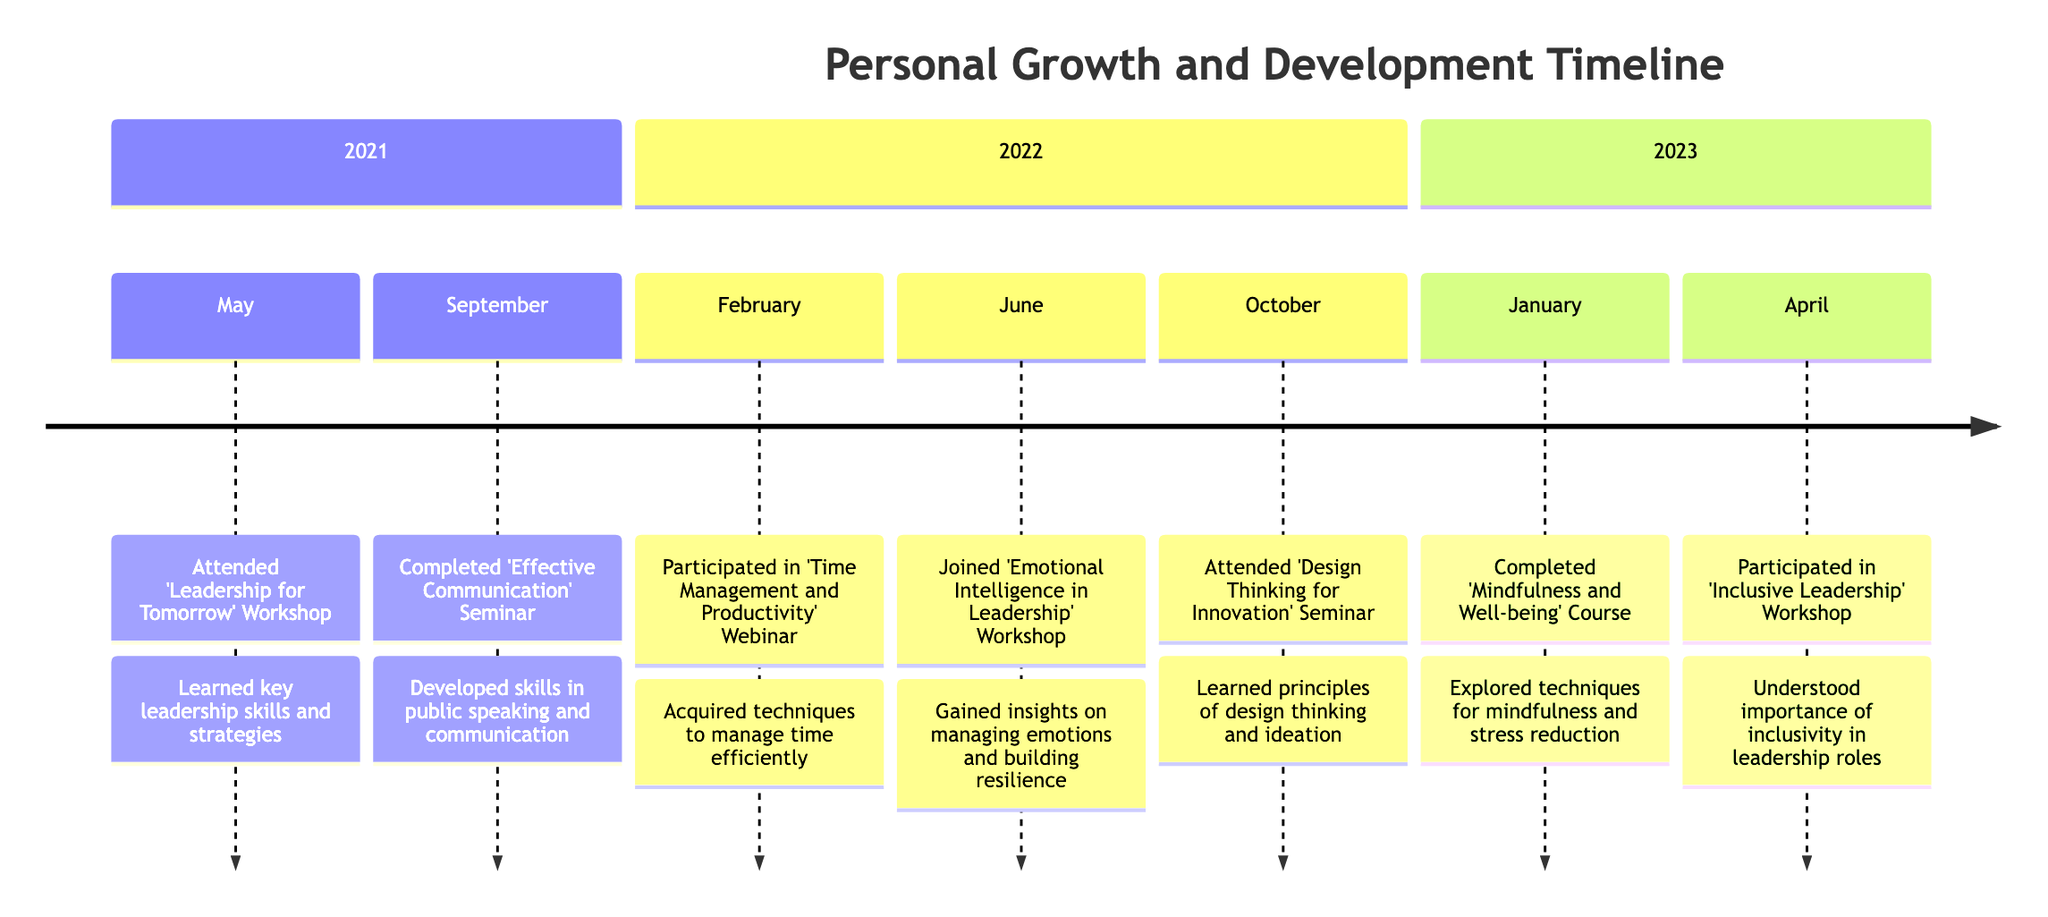What is the title of the timeline? The title is provided at the top of the diagram and states the overall theme of the timeline, specifically focusing on personal growth and development experiences over a specified period.
Answer: Personal Growth and Development Timeline How many workshops are included in the timeline? To determine this, we count the events categorized as workshops within the timeline. According to the entries listed, there are a total of four workshops, including both participating and joined activities.
Answer: 4 Which event occurred in January 2023? By looking at the section for 2023, we find the specific event listed under January, which directly indicates what took place during that month.
Answer: Completed 'Mindfulness and Well-being' Course What skill was developed during the 'Effective Communication' Seminar? The description associated with the 'Effective Communication' Seminar provides information about the specific skills gained from it, highlighting the primary focus of the seminar.
Answer: Public speaking Which workshop focused on emotional intelligence? By reviewing the events listed under the 2022 section, we identify the workshop that specifically emphasizes emotional intelligence, distinguishing it from other events.
Answer: 'Emotional Intelligence in Leadership' Workshop In which month was the 'Inclusive Leadership' Workshop held? We can pinpoint the month by checking the timeline section for 2023 and locating the event that corresponds to 'Inclusive Leadership,' confirming when it took place.
Answer: April What was a key learning from the 'Design Thinking for Innovation' Seminar? The timeline's description for this seminar indicates the primary learning outcome or principle that was emphasized, summarizing the aim of participation in the seminar.
Answer: Principles of design thinking How many months passed between the 'Leadership for Tomorrow' Workshop and the 'Effective Communication' Seminar? To find the number of months between these two events, we compare their dates: the workshop in May 2021 and the seminar in September 2021, and perform a simple calculation of the intervening months.
Answer: 4 What was the main theme of the course completed in January 2023? The description for the course specifies the central focus and objectives, summarizing what aspects of personal growth were targeted through the course content.
Answer: Mindfulness and stress reduction 